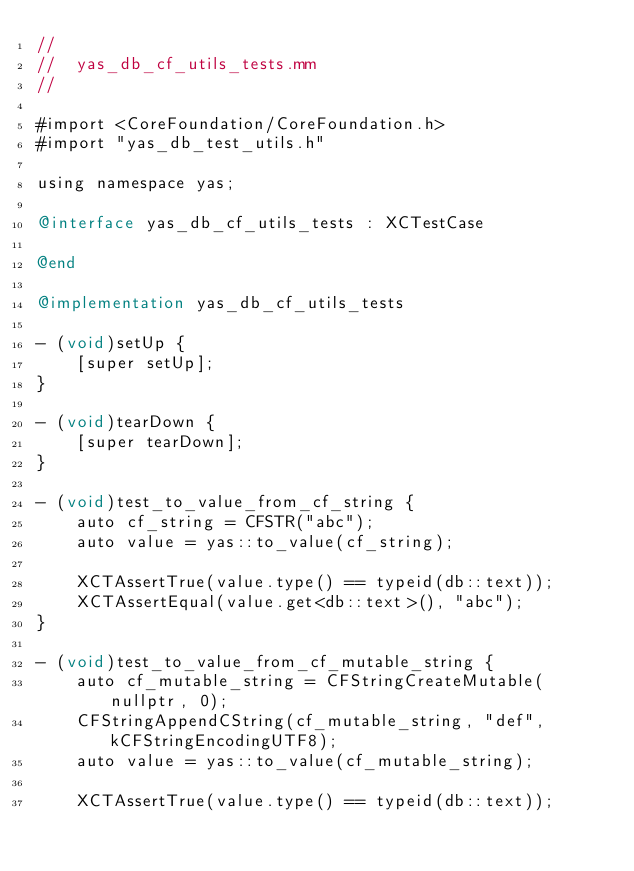Convert code to text. <code><loc_0><loc_0><loc_500><loc_500><_ObjectiveC_>//
//  yas_db_cf_utils_tests.mm
//

#import <CoreFoundation/CoreFoundation.h>
#import "yas_db_test_utils.h"

using namespace yas;

@interface yas_db_cf_utils_tests : XCTestCase

@end

@implementation yas_db_cf_utils_tests

- (void)setUp {
    [super setUp];
}

- (void)tearDown {
    [super tearDown];
}

- (void)test_to_value_from_cf_string {
    auto cf_string = CFSTR("abc");
    auto value = yas::to_value(cf_string);

    XCTAssertTrue(value.type() == typeid(db::text));
    XCTAssertEqual(value.get<db::text>(), "abc");
}

- (void)test_to_value_from_cf_mutable_string {
    auto cf_mutable_string = CFStringCreateMutable(nullptr, 0);
    CFStringAppendCString(cf_mutable_string, "def", kCFStringEncodingUTF8);
    auto value = yas::to_value(cf_mutable_string);

    XCTAssertTrue(value.type() == typeid(db::text));</code> 